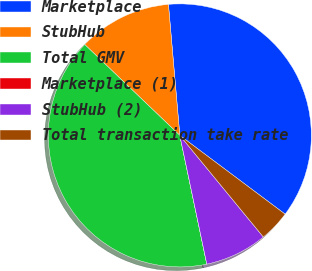<chart> <loc_0><loc_0><loc_500><loc_500><pie_chart><fcel>Marketplace<fcel>StubHub<fcel>Total GMV<fcel>Marketplace (1)<fcel>StubHub (2)<fcel>Total transaction take rate<nl><fcel>36.6%<fcel>11.48%<fcel>40.43%<fcel>0.0%<fcel>7.66%<fcel>3.83%<nl></chart> 